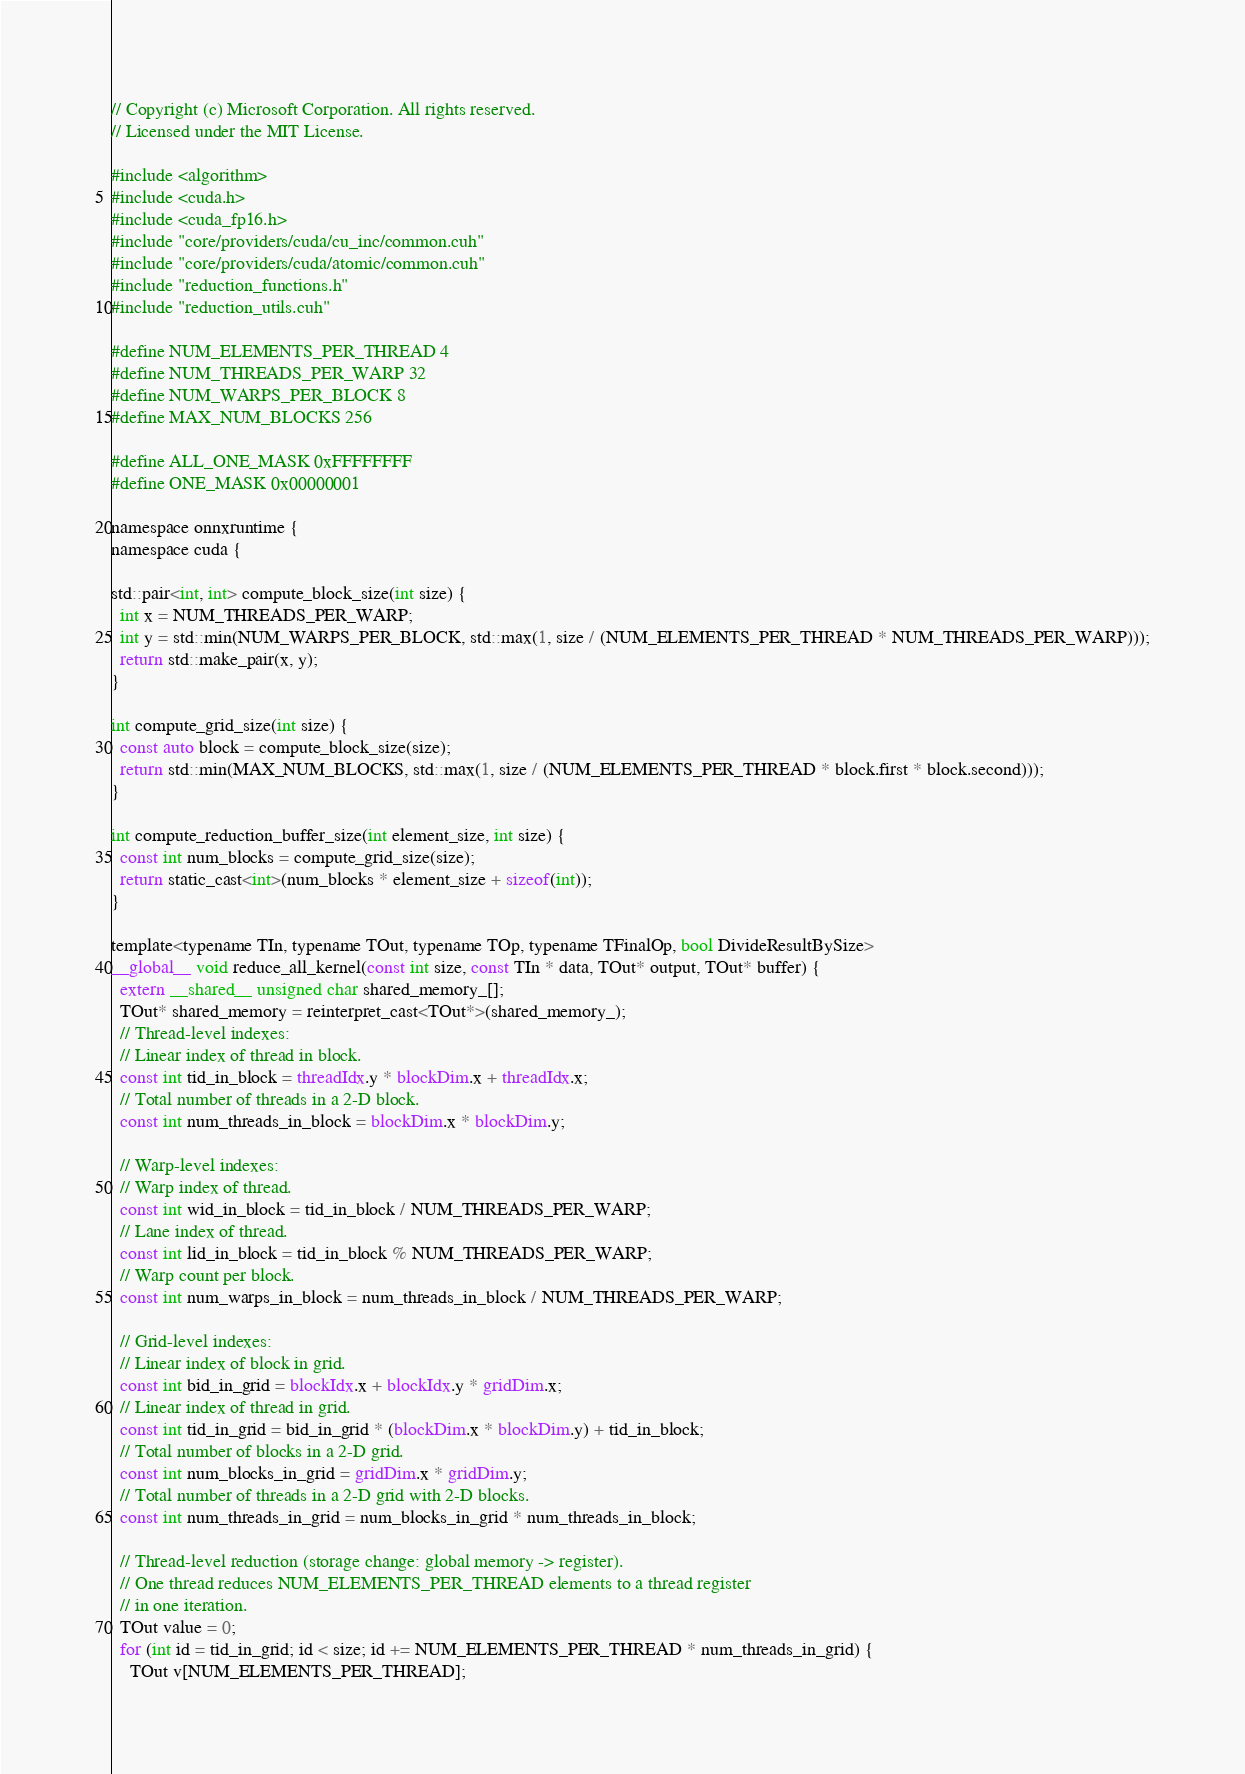Convert code to text. <code><loc_0><loc_0><loc_500><loc_500><_Cuda_>// Copyright (c) Microsoft Corporation. All rights reserved.
// Licensed under the MIT License.

#include <algorithm>
#include <cuda.h>
#include <cuda_fp16.h>
#include "core/providers/cuda/cu_inc/common.cuh"
#include "core/providers/cuda/atomic/common.cuh"
#include "reduction_functions.h"
#include "reduction_utils.cuh"

#define NUM_ELEMENTS_PER_THREAD 4
#define NUM_THREADS_PER_WARP 32
#define NUM_WARPS_PER_BLOCK 8
#define MAX_NUM_BLOCKS 256

#define ALL_ONE_MASK 0xFFFFFFFF
#define ONE_MASK 0x00000001

namespace onnxruntime {
namespace cuda {

std::pair<int, int> compute_block_size(int size) {
  int x = NUM_THREADS_PER_WARP;
  int y = std::min(NUM_WARPS_PER_BLOCK, std::max(1, size / (NUM_ELEMENTS_PER_THREAD * NUM_THREADS_PER_WARP)));
  return std::make_pair(x, y);
}

int compute_grid_size(int size) {
  const auto block = compute_block_size(size);
  return std::min(MAX_NUM_BLOCKS, std::max(1, size / (NUM_ELEMENTS_PER_THREAD * block.first * block.second)));
}

int compute_reduction_buffer_size(int element_size, int size) {
  const int num_blocks = compute_grid_size(size);
  return static_cast<int>(num_blocks * element_size + sizeof(int));
}

template<typename TIn, typename TOut, typename TOp, typename TFinalOp, bool DivideResultBySize>
__global__ void reduce_all_kernel(const int size, const TIn * data, TOut* output, TOut* buffer) {
  extern __shared__ unsigned char shared_memory_[];
  TOut* shared_memory = reinterpret_cast<TOut*>(shared_memory_);
  // Thread-level indexes:
  // Linear index of thread in block.
  const int tid_in_block = threadIdx.y * blockDim.x + threadIdx.x;
  // Total number of threads in a 2-D block.
  const int num_threads_in_block = blockDim.x * blockDim.y;

  // Warp-level indexes:
  // Warp index of thread.
  const int wid_in_block = tid_in_block / NUM_THREADS_PER_WARP;
  // Lane index of thread.
  const int lid_in_block = tid_in_block % NUM_THREADS_PER_WARP;
  // Warp count per block.
  const int num_warps_in_block = num_threads_in_block / NUM_THREADS_PER_WARP;

  // Grid-level indexes:
  // Linear index of block in grid.
  const int bid_in_grid = blockIdx.x + blockIdx.y * gridDim.x;
  // Linear index of thread in grid.
  const int tid_in_grid = bid_in_grid * (blockDim.x * blockDim.y) + tid_in_block;
  // Total number of blocks in a 2-D grid.
  const int num_blocks_in_grid = gridDim.x * gridDim.y;
  // Total number of threads in a 2-D grid with 2-D blocks.
  const int num_threads_in_grid = num_blocks_in_grid * num_threads_in_block;

  // Thread-level reduction (storage change: global memory -> register).
  // One thread reduces NUM_ELEMENTS_PER_THREAD elements to a thread register
  // in one iteration.
  TOut value = 0;
  for (int id = tid_in_grid; id < size; id += NUM_ELEMENTS_PER_THREAD * num_threads_in_grid) {
    TOut v[NUM_ELEMENTS_PER_THREAD];
</code> 